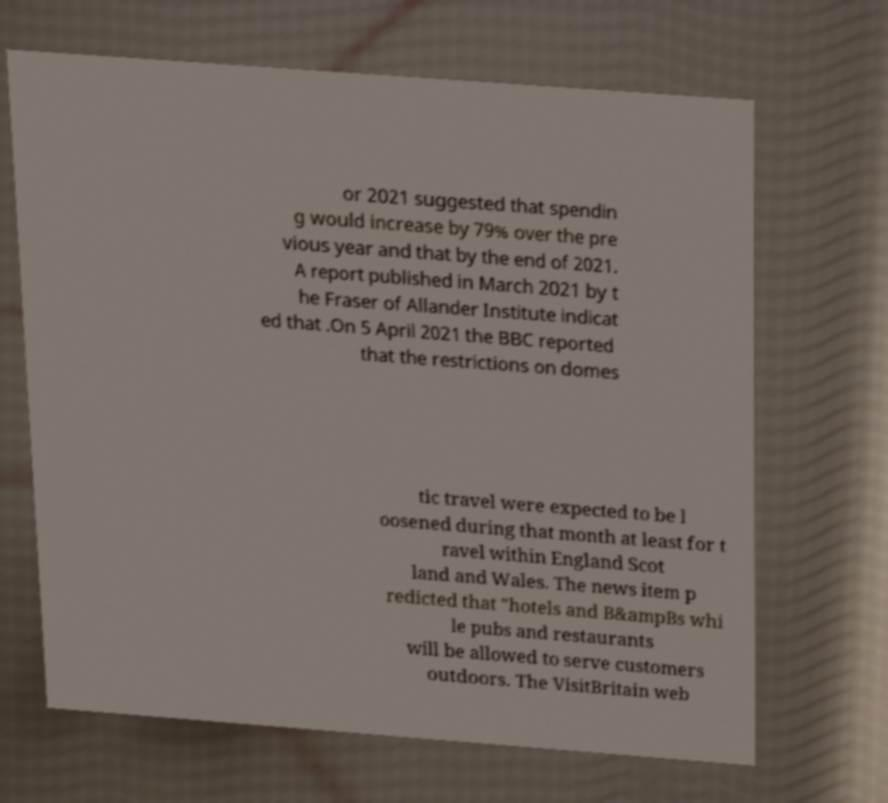Could you extract and type out the text from this image? or 2021 suggested that spendin g would increase by 79% over the pre vious year and that by the end of 2021. A report published in March 2021 by t he Fraser of Allander Institute indicat ed that .On 5 April 2021 the BBC reported that the restrictions on domes tic travel were expected to be l oosened during that month at least for t ravel within England Scot land and Wales. The news item p redicted that "hotels and B&ampBs whi le pubs and restaurants will be allowed to serve customers outdoors. The VisitBritain web 